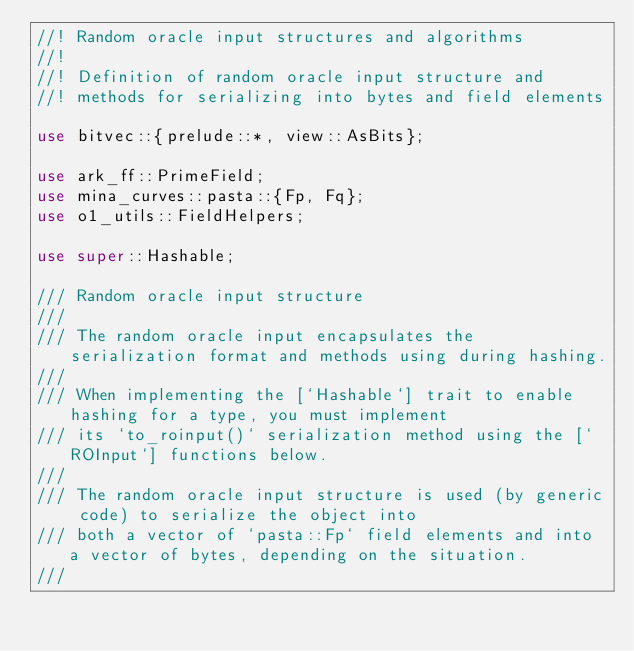<code> <loc_0><loc_0><loc_500><loc_500><_Rust_>//! Random oracle input structures and algorithms
//!
//! Definition of random oracle input structure and
//! methods for serializing into bytes and field elements

use bitvec::{prelude::*, view::AsBits};

use ark_ff::PrimeField;
use mina_curves::pasta::{Fp, Fq};
use o1_utils::FieldHelpers;

use super::Hashable;

/// Random oracle input structure
///
/// The random oracle input encapsulates the serialization format and methods using during hashing.
///
/// When implementing the [`Hashable`] trait to enable hashing for a type, you must implement
/// its `to_roinput()` serialization method using the [`ROInput`] functions below.
///
/// The random oracle input structure is used (by generic code) to serialize the object into
/// both a vector of `pasta::Fp` field elements and into a vector of bytes, depending on the situation.
///</code> 